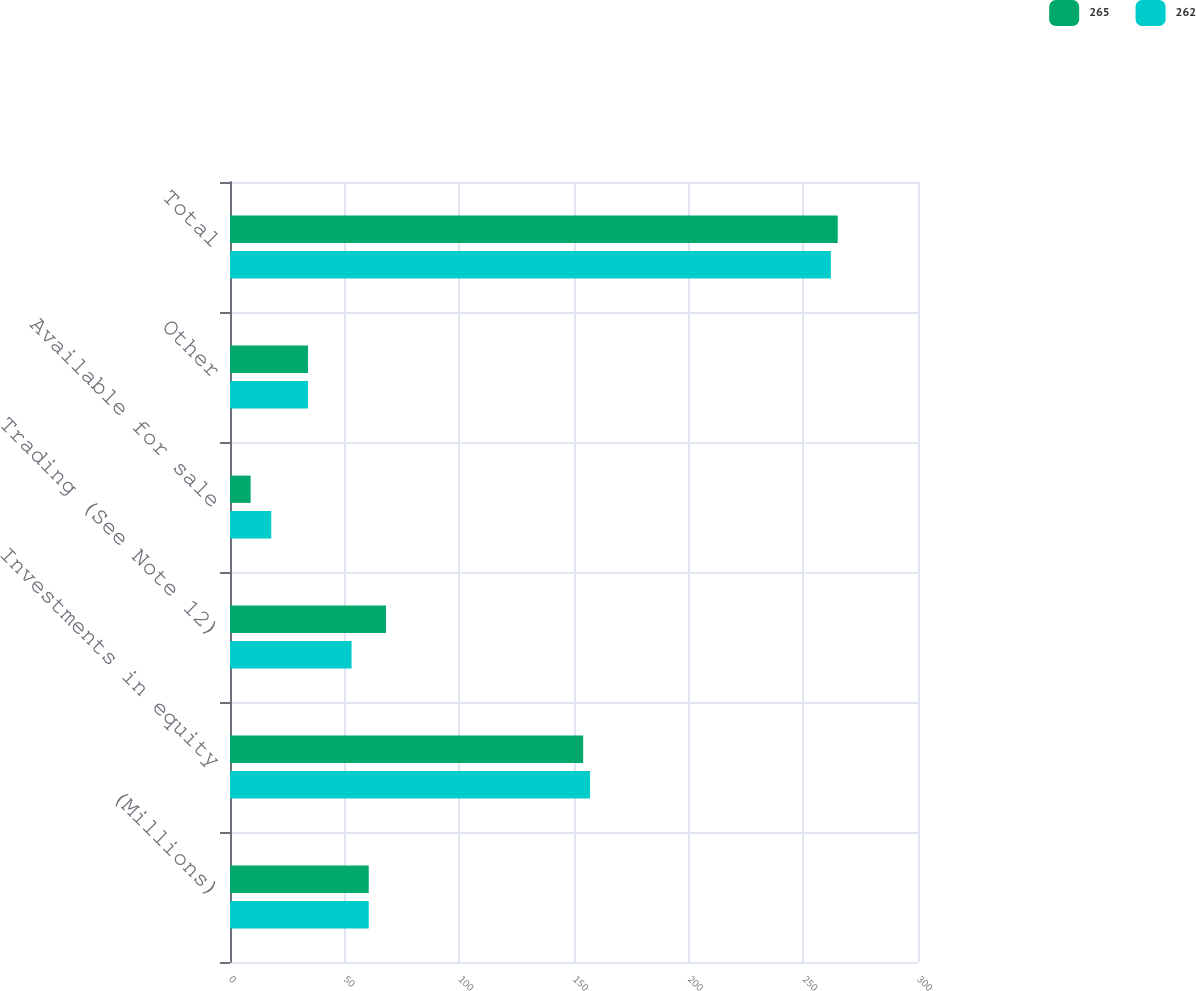<chart> <loc_0><loc_0><loc_500><loc_500><stacked_bar_chart><ecel><fcel>(Millions)<fcel>Investments in equity<fcel>Trading (See Note 12)<fcel>Available for sale<fcel>Other<fcel>Total<nl><fcel>265<fcel>60.5<fcel>154<fcel>68<fcel>9<fcel>34<fcel>265<nl><fcel>262<fcel>60.5<fcel>157<fcel>53<fcel>18<fcel>34<fcel>262<nl></chart> 